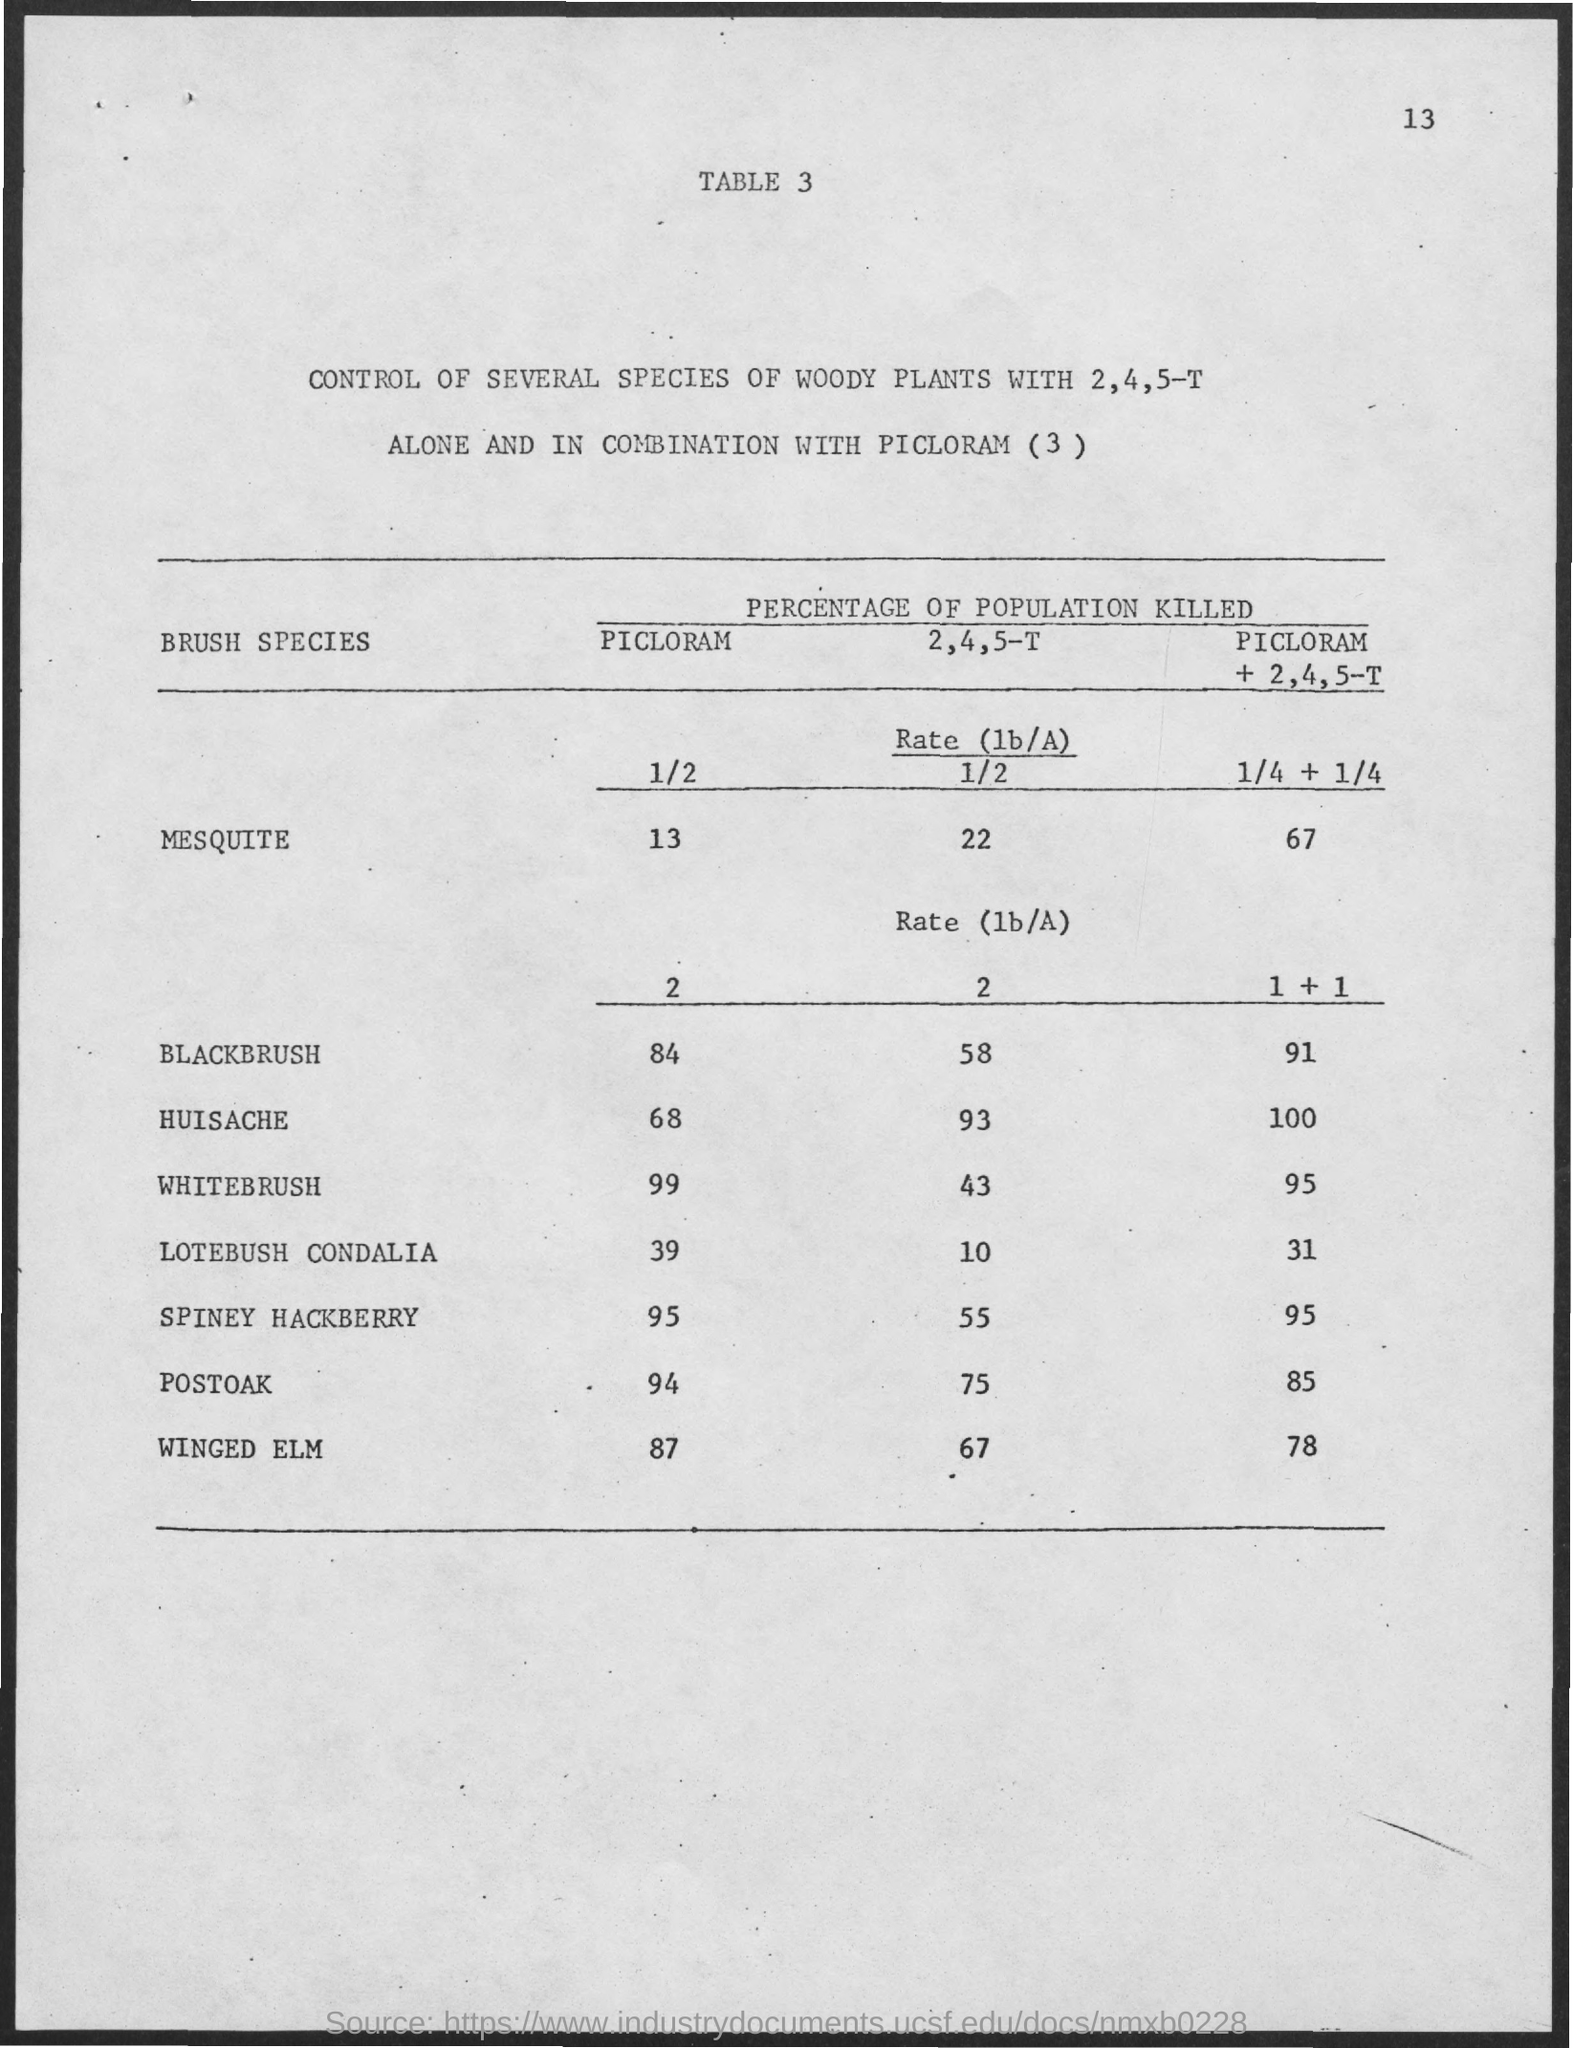What is the percentage of Blackbrush killed with PICLORAM?
Offer a terse response. 84. What is the percentage of Huisache killed with PICLORAM?
Your answer should be very brief. 68. What is the percentage of Whitebrush killed with PICLORAM?
Provide a short and direct response. 99. What is the percentage of Lotebush Condalia killed with PICLORAM?
Ensure brevity in your answer.  39. What is the percentage of Spiney Hackberry killed with PICLORAM?
Give a very brief answer. 95. What is the percentage of Postoak killed with PICLORAM?
Your answer should be very brief. 94. What is the percentage of Winged Elm killed with PICLORAM?
Ensure brevity in your answer.  87. What is the percentage of Blackbrush killed with 2,4,5-T?
Make the answer very short. 58. What is the percentage of Whitebrush killed with 2,4,5-T?
Ensure brevity in your answer.  43. What is the percentage of Huisache killed with 2,4,5-T?
Ensure brevity in your answer.  93. 